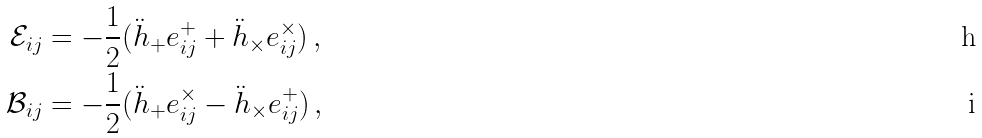<formula> <loc_0><loc_0><loc_500><loc_500>\mathcal { E } _ { i j } & = - \frac { 1 } { 2 } ( \ddot { h } _ { + } e ^ { + } _ { i j } + \ddot { h } _ { \times } e ^ { \times } _ { i j } ) \, , \\ \mathcal { B } _ { i j } & = - \frac { 1 } { 2 } ( \ddot { h } _ { + } e ^ { \times } _ { i j } - \ddot { h } _ { \times } e ^ { + } _ { i j } ) \, ,</formula> 